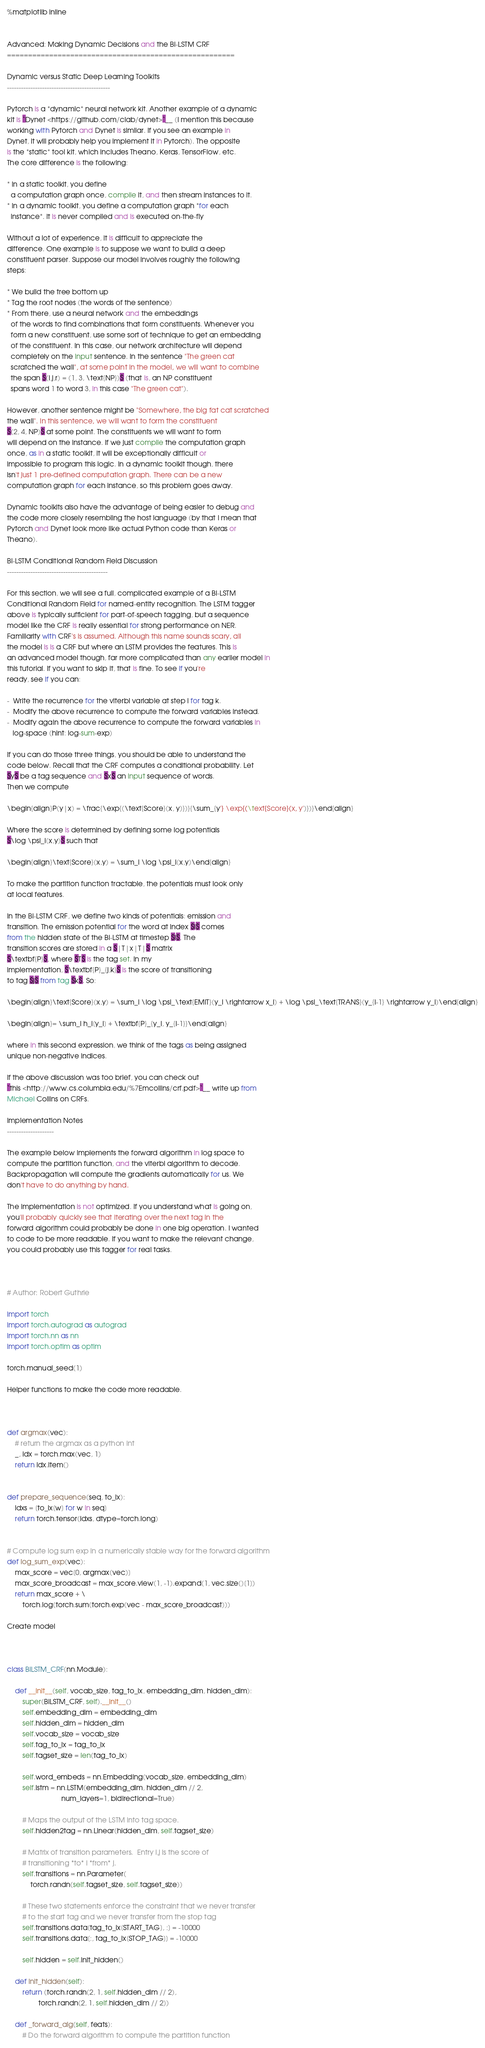Convert code to text. <code><loc_0><loc_0><loc_500><loc_500><_Python_>%matplotlib inline


Advanced: Making Dynamic Decisions and the Bi-LSTM CRF
======================================================

Dynamic versus Static Deep Learning Toolkits
--------------------------------------------

Pytorch is a *dynamic* neural network kit. Another example of a dynamic
kit is `Dynet <https://github.com/clab/dynet>`__ (I mention this because
working with Pytorch and Dynet is similar. If you see an example in
Dynet, it will probably help you implement it in Pytorch). The opposite
is the *static* tool kit, which includes Theano, Keras, TensorFlow, etc.
The core difference is the following:

* In a static toolkit, you define
  a computation graph once, compile it, and then stream instances to it.
* In a dynamic toolkit, you define a computation graph *for each
  instance*. It is never compiled and is executed on-the-fly

Without a lot of experience, it is difficult to appreciate the
difference. One example is to suppose we want to build a deep
constituent parser. Suppose our model involves roughly the following
steps:

* We build the tree bottom up
* Tag the root nodes (the words of the sentence)
* From there, use a neural network and the embeddings
  of the words to find combinations that form constituents. Whenever you
  form a new constituent, use some sort of technique to get an embedding
  of the constituent. In this case, our network architecture will depend
  completely on the input sentence. In the sentence "The green cat
  scratched the wall", at some point in the model, we will want to combine
  the span $(i,j,r) = (1, 3, \text{NP})$ (that is, an NP constituent
  spans word 1 to word 3, in this case "The green cat").

However, another sentence might be "Somewhere, the big fat cat scratched
the wall". In this sentence, we will want to form the constituent
$(2, 4, NP)$ at some point. The constituents we will want to form
will depend on the instance. If we just compile the computation graph
once, as in a static toolkit, it will be exceptionally difficult or
impossible to program this logic. In a dynamic toolkit though, there
isn't just 1 pre-defined computation graph. There can be a new
computation graph for each instance, so this problem goes away.

Dynamic toolkits also have the advantage of being easier to debug and
the code more closely resembling the host language (by that I mean that
Pytorch and Dynet look more like actual Python code than Keras or
Theano).

Bi-LSTM Conditional Random Field Discussion
-------------------------------------------

For this section, we will see a full, complicated example of a Bi-LSTM
Conditional Random Field for named-entity recognition. The LSTM tagger
above is typically sufficient for part-of-speech tagging, but a sequence
model like the CRF is really essential for strong performance on NER.
Familiarity with CRF's is assumed. Although this name sounds scary, all
the model is is a CRF but where an LSTM provides the features. This is
an advanced model though, far more complicated than any earlier model in
this tutorial. If you want to skip it, that is fine. To see if you're
ready, see if you can:

-  Write the recurrence for the viterbi variable at step i for tag k.
-  Modify the above recurrence to compute the forward variables instead.
-  Modify again the above recurrence to compute the forward variables in
   log-space (hint: log-sum-exp)

If you can do those three things, you should be able to understand the
code below. Recall that the CRF computes a conditional probability. Let
$y$ be a tag sequence and $x$ an input sequence of words.
Then we compute

\begin{align}P(y|x) = \frac{\exp{(\text{Score}(x, y)})}{\sum_{y'} \exp{(\text{Score}(x, y')})}\end{align}

Where the score is determined by defining some log potentials
$\log \psi_i(x,y)$ such that

\begin{align}\text{Score}(x,y) = \sum_i \log \psi_i(x,y)\end{align}

To make the partition function tractable, the potentials must look only
at local features.

In the Bi-LSTM CRF, we define two kinds of potentials: emission and
transition. The emission potential for the word at index $i$ comes
from the hidden state of the Bi-LSTM at timestep $i$. The
transition scores are stored in a $|T|x|T|$ matrix
$\textbf{P}$, where $T$ is the tag set. In my
implementation, $\textbf{P}_{j,k}$ is the score of transitioning
to tag $j$ from tag $k$. So:

\begin{align}\text{Score}(x,y) = \sum_i \log \psi_\text{EMIT}(y_i \rightarrow x_i) + \log \psi_\text{TRANS}(y_{i-1} \rightarrow y_i)\end{align}

\begin{align}= \sum_i h_i[y_i] + \textbf{P}_{y_i, y_{i-1}}\end{align}

where in this second expression, we think of the tags as being assigned
unique non-negative indices.

If the above discussion was too brief, you can check out
`this <http://www.cs.columbia.edu/%7Emcollins/crf.pdf>`__ write up from
Michael Collins on CRFs.

Implementation Notes
--------------------

The example below implements the forward algorithm in log space to
compute the partition function, and the viterbi algorithm to decode.
Backpropagation will compute the gradients automatically for us. We
don't have to do anything by hand.

The implementation is not optimized. If you understand what is going on,
you'll probably quickly see that iterating over the next tag in the
forward algorithm could probably be done in one big operation. I wanted
to code to be more readable. If you want to make the relevant change,
you could probably use this tagger for real tasks.



# Author: Robert Guthrie

import torch
import torch.autograd as autograd
import torch.nn as nn
import torch.optim as optim

torch.manual_seed(1)

Helper functions to make the code more readable.



def argmax(vec):
    # return the argmax as a python int
    _, idx = torch.max(vec, 1)
    return idx.item()


def prepare_sequence(seq, to_ix):
    idxs = [to_ix[w] for w in seq]
    return torch.tensor(idxs, dtype=torch.long)


# Compute log sum exp in a numerically stable way for the forward algorithm
def log_sum_exp(vec):
    max_score = vec[0, argmax(vec)]
    max_score_broadcast = max_score.view(1, -1).expand(1, vec.size()[1])
    return max_score + \
        torch.log(torch.sum(torch.exp(vec - max_score_broadcast)))

Create model



class BiLSTM_CRF(nn.Module):

    def __init__(self, vocab_size, tag_to_ix, embedding_dim, hidden_dim):
        super(BiLSTM_CRF, self).__init__()
        self.embedding_dim = embedding_dim
        self.hidden_dim = hidden_dim
        self.vocab_size = vocab_size
        self.tag_to_ix = tag_to_ix
        self.tagset_size = len(tag_to_ix)

        self.word_embeds = nn.Embedding(vocab_size, embedding_dim)
        self.lstm = nn.LSTM(embedding_dim, hidden_dim // 2,
                            num_layers=1, bidirectional=True)

        # Maps the output of the LSTM into tag space.
        self.hidden2tag = nn.Linear(hidden_dim, self.tagset_size)

        # Matrix of transition parameters.  Entry i,j is the score of
        # transitioning *to* i *from* j.
        self.transitions = nn.Parameter(
            torch.randn(self.tagset_size, self.tagset_size))

        # These two statements enforce the constraint that we never transfer
        # to the start tag and we never transfer from the stop tag
        self.transitions.data[tag_to_ix[START_TAG], :] = -10000
        self.transitions.data[:, tag_to_ix[STOP_TAG]] = -10000

        self.hidden = self.init_hidden()

    def init_hidden(self):
        return (torch.randn(2, 1, self.hidden_dim // 2),
                torch.randn(2, 1, self.hidden_dim // 2))

    def _forward_alg(self, feats):
        # Do the forward algorithm to compute the partition function</code> 